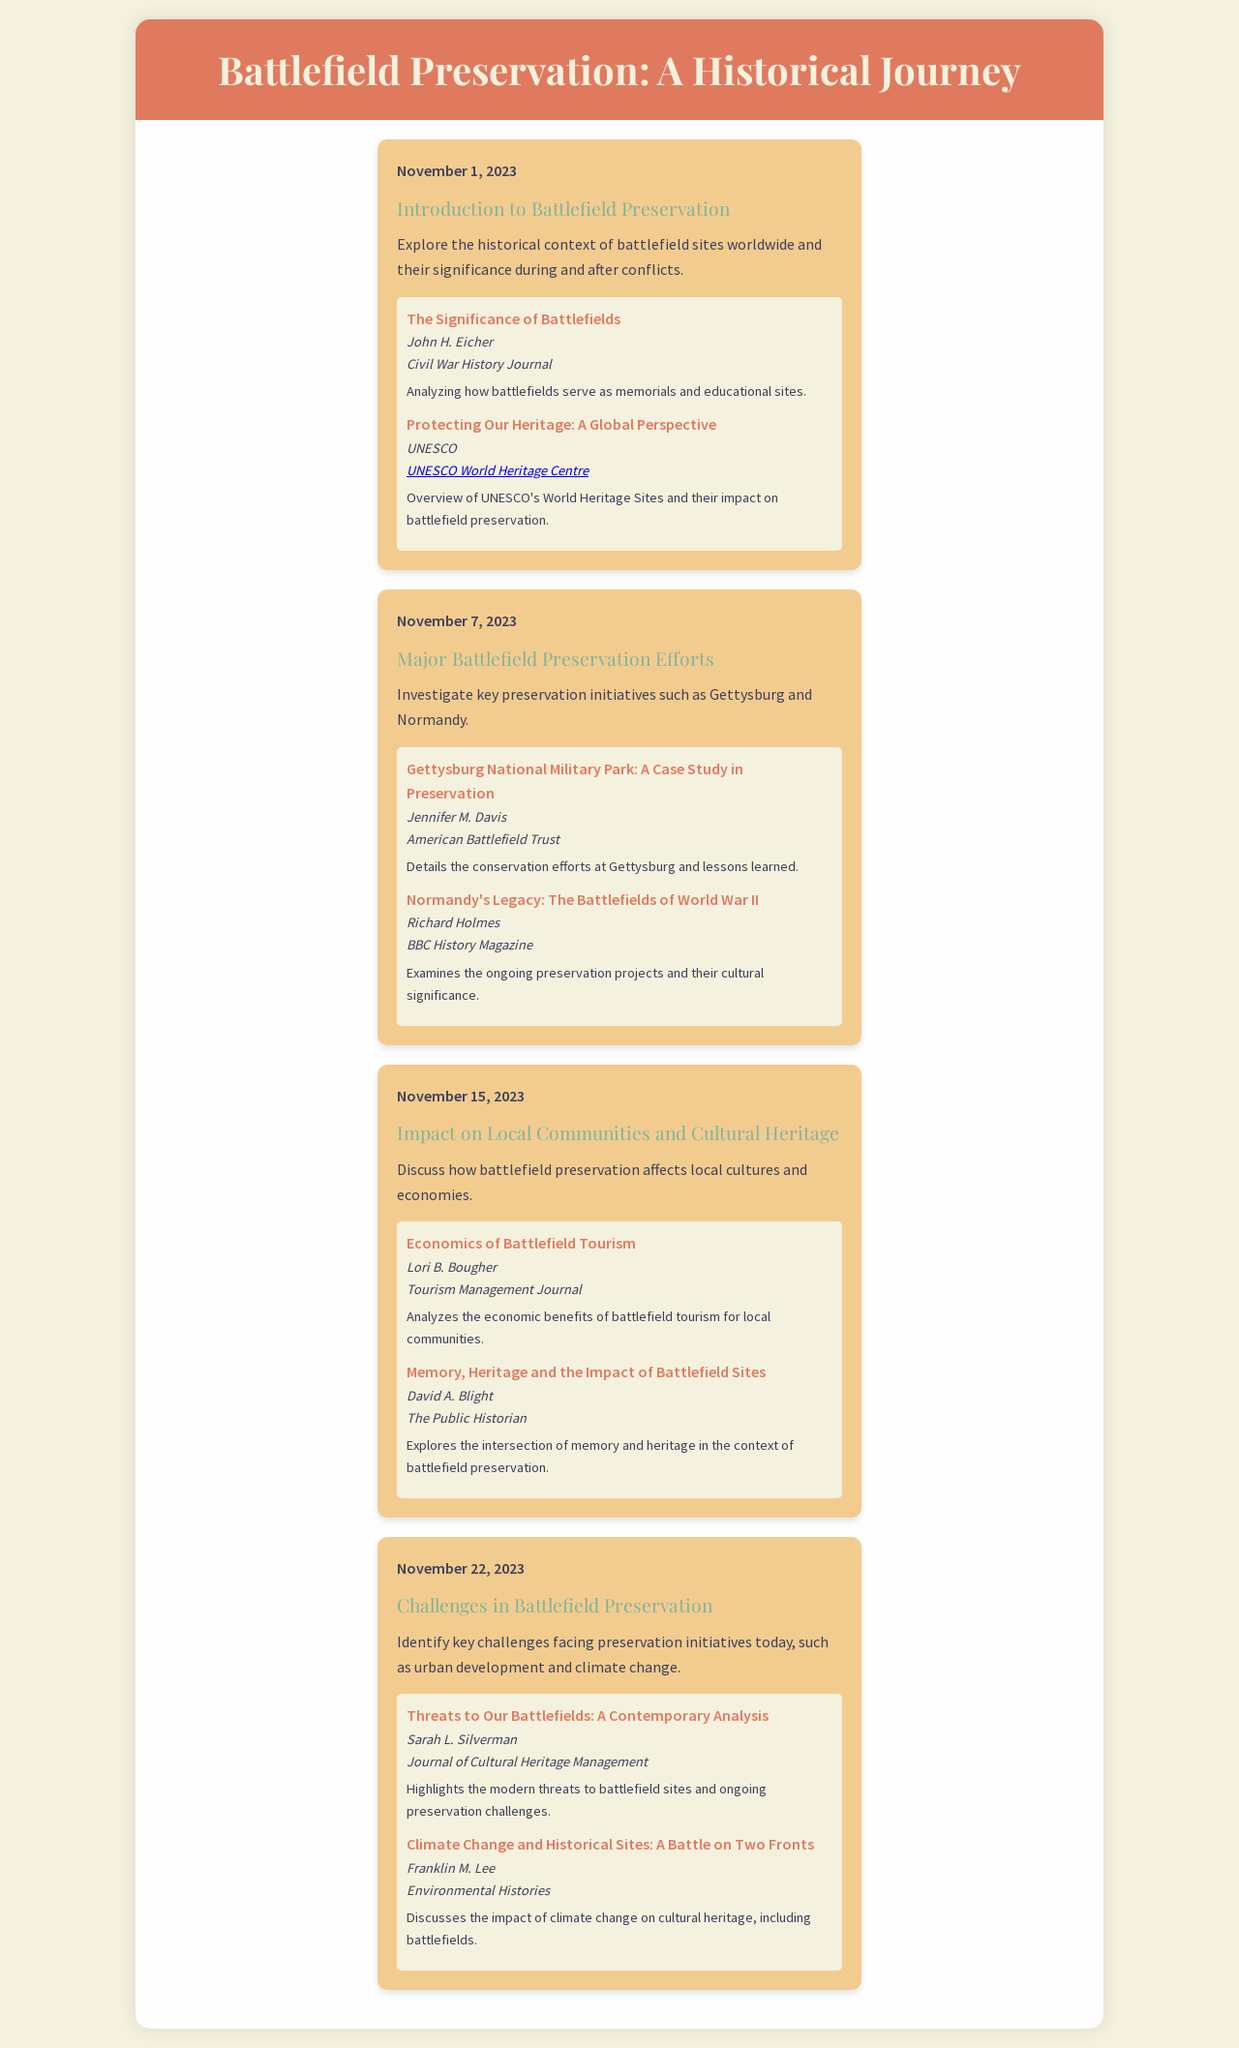What is the date for the introduction to battlefield preservation? The date for this event is specifically mentioned in the schedule as November 1, 2023.
Answer: November 1, 2023 Who authored "Gettysburg National Military Park: A Case Study in Preservation"? This resource is authored by Jennifer M. Davis, as indicated in the respective schedule item.
Answer: Jennifer M. Davis What topic is discussed on November 15, 2023? The topic discussed on this date revolves around the impact of battlefield preservation on local communities and cultural heritage.
Answer: Impact on Local Communities and Cultural Heritage Which publication features the article "Threats to Our Battlefields: A Contemporary Analysis"? This article is featured in the Journal of Cultural Heritage Management, as stated in the resources section.
Answer: Journal of Cultural Heritage Management What is a key challenge in battlefield preservation mentioned in the document? The document lists urban development and climate change as key challenges faced by preservation initiatives today.
Answer: Urban development and climate change What is the main focus of the activity scheduled for November 7, 2023? The main focus for this date involves investigating key preservation initiatives such as Gettysburg and Normandy.
Answer: Investigate key preservation initiatives Which report discusses the economic benefits of battlefield tourism? "Economics of Battlefield Tourism" is the report that discusses this aspect and is authored by Lori B. Bougher.
Answer: Economics of Battlefield Tourism How many resources are provided for the topic of "Introduction to Battlefield Preservation"? There are two resources listed for this specific topic in the schedule.
Answer: Two 